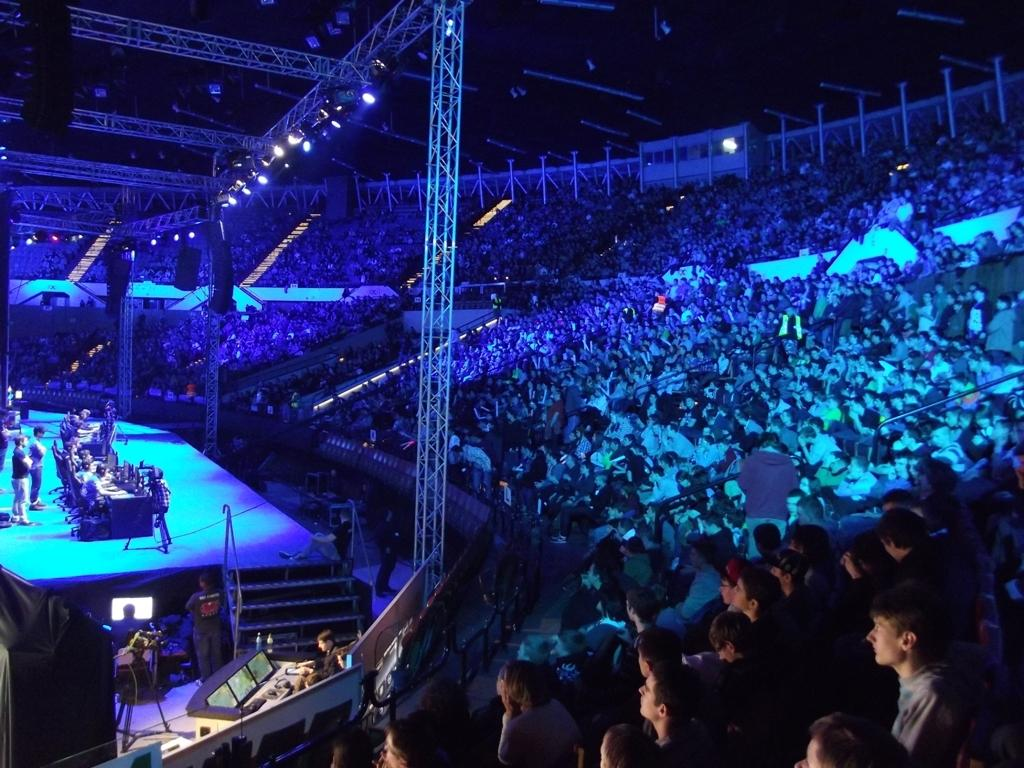What is the main feature of the picture? There is a dais in the picture. What is happening on the dais? People are sitting on the chairs on the dais. Where is the audience located in the picture? The audience is on the right side of the picture. Is there a porter carrying luggage in the image? There is no porter or luggage present in the image. 